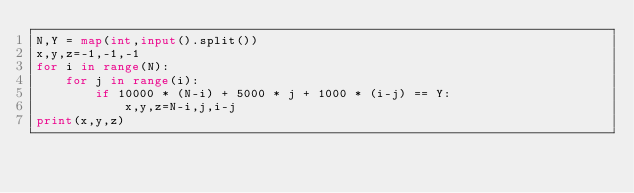<code> <loc_0><loc_0><loc_500><loc_500><_Python_>N,Y = map(int,input().split())
x,y,z=-1,-1,-1
for i in range(N):
    for j in range(i):
        if 10000 * (N-i) + 5000 * j + 1000 * (i-j) == Y:
            x,y,z=N-i,j,i-j
print(x,y,z)</code> 